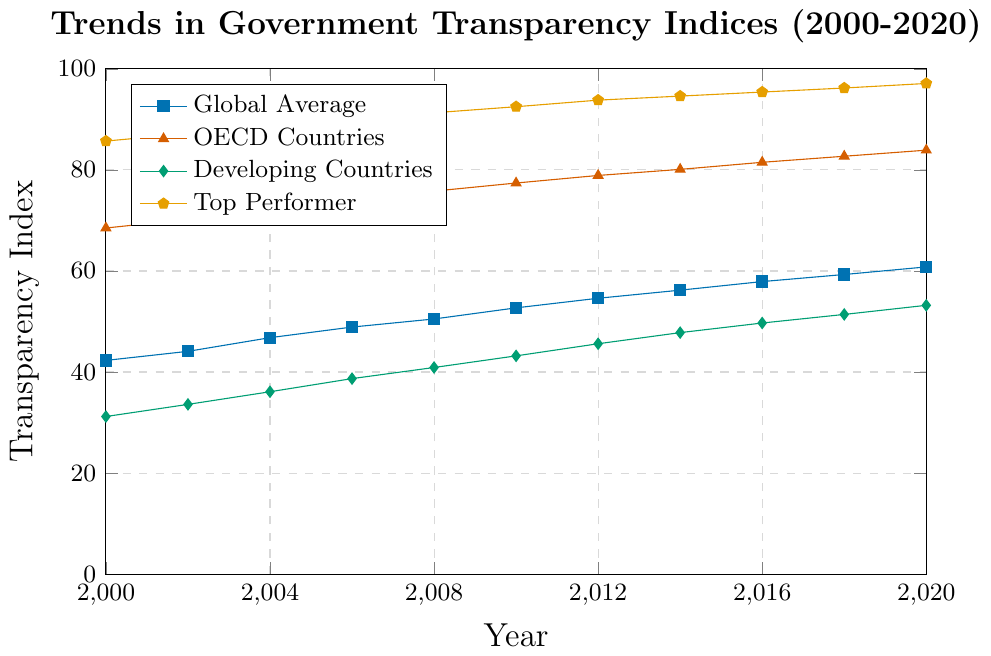What is the trend of the Global Average Transparency Index from 2000 to 2020? The Global Average Transparency Index consistently increases from 42.3 in 2000 to 60.8 in 2020. The trend shows a steady upward progression.
Answer: Steadily increasing How did the Developing Countries Average change between 2000 and 2020? The Developing Countries Average Transparency Index starts at 31.2 in 2000 and increases to 53.2 by 2020, showing a consistent upward trend.
Answer: Increased In which year did the OECD Countries Average first exceed 80? Identifying the point where the OECD Countries Average exceeds 80, we see it first reaches above 80 in the year 2014.
Answer: 2014 Which group has the highest Transparency Index in 2020? By comparing the Transparency Indices in 2020, the Top Performer Score of 97.1 is the highest among all groups.
Answer: Top Performer How much did the Top Performer Score increase from 2000 to 2020? The Top Performer Score increased from 85.7 in 2000 to 97.1 in 2020. The difference is calculated as 97.1 - 85.7 = 11.4.
Answer: 11.4 What is the average Global Transparency Index across the years provided? Summing the Global Average values from 2000-2020 and dividing by the number of years: (42.3+44.1+46.8+48.9+50.5+52.7+54.6+56.2+57.9+59.3+60.8) / 11 = 52.82.
Answer: 52.82 Which year saw the highest Transparency Index for the Developing Countries Average? Comparing the Developing Countries Average values for all given years, 2020 marks the highest at 53.2.
Answer: 2020 What is the difference in the OECD Countries Average between 2016 and 2020? The OECD Countries Average in 2016 is 81.5 and in 2020 is 83.9. The difference is 83.9 - 81.5 = 2.4.
Answer: 2.4 In which year did the Global Average Transparency Index first exceed 50? The Global Average Transparency Index first exceeds 50 in the year 2008, where it is 50.5.
Answer: 2008 Compare the Global Average Transparency Index and the Developing Countries Average in 2010. In 2010, the Global Average is 52.7 and the Developing Countries Average is 43.2. Therefore, the Global Average is higher than the Developing Countries Average by 52.7 - 43.2 = 9.5.
Answer: Global Average is higher by 9.5 